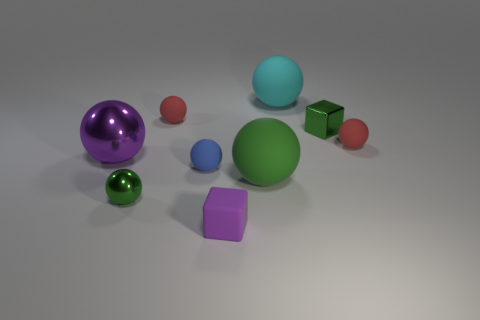Subtract 3 balls. How many balls are left? 4 Subtract all purple spheres. How many spheres are left? 6 Subtract all large purple spheres. How many spheres are left? 6 Add 1 green rubber blocks. How many objects exist? 10 Subtract all green balls. Subtract all blue cylinders. How many balls are left? 5 Subtract all cubes. How many objects are left? 7 Subtract all cyan spheres. Subtract all big objects. How many objects are left? 5 Add 6 purple blocks. How many purple blocks are left? 7 Add 7 brown rubber balls. How many brown rubber balls exist? 7 Subtract 0 cyan cylinders. How many objects are left? 9 